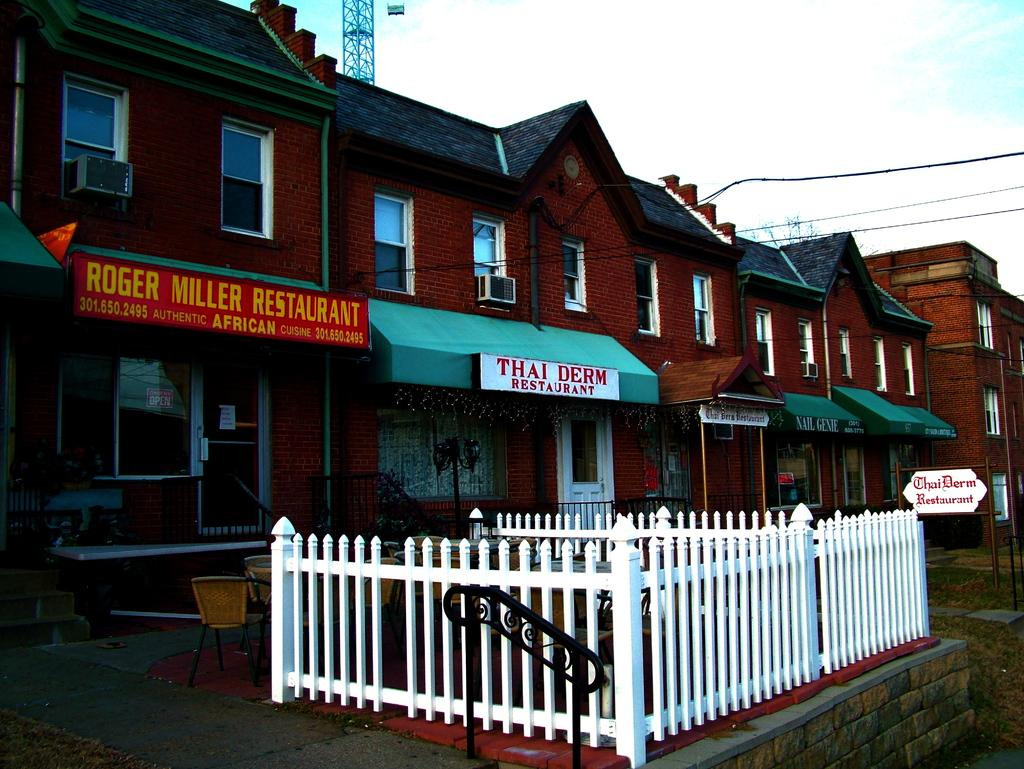What type of establishment is shown in the image? There is a front view of a restaurant in the image. What other structures are visible in the image? There is a building in the image. Are there any vehicles present in the image? Yes, there are cars in the image. What architectural features can be seen in the image? There are staircases in the image. What can be seen in the sky in the image? The sky is visible in the image. What else is present in the image besides the restaurant, building, cars, and staircases? There are wires in the image. How many cakes are displayed on the door in the image? There are no cakes displayed on the door in the image, as the image does not show a door. What type of weapon is present in the image? There is no weapon present in the image, including a cannon. 